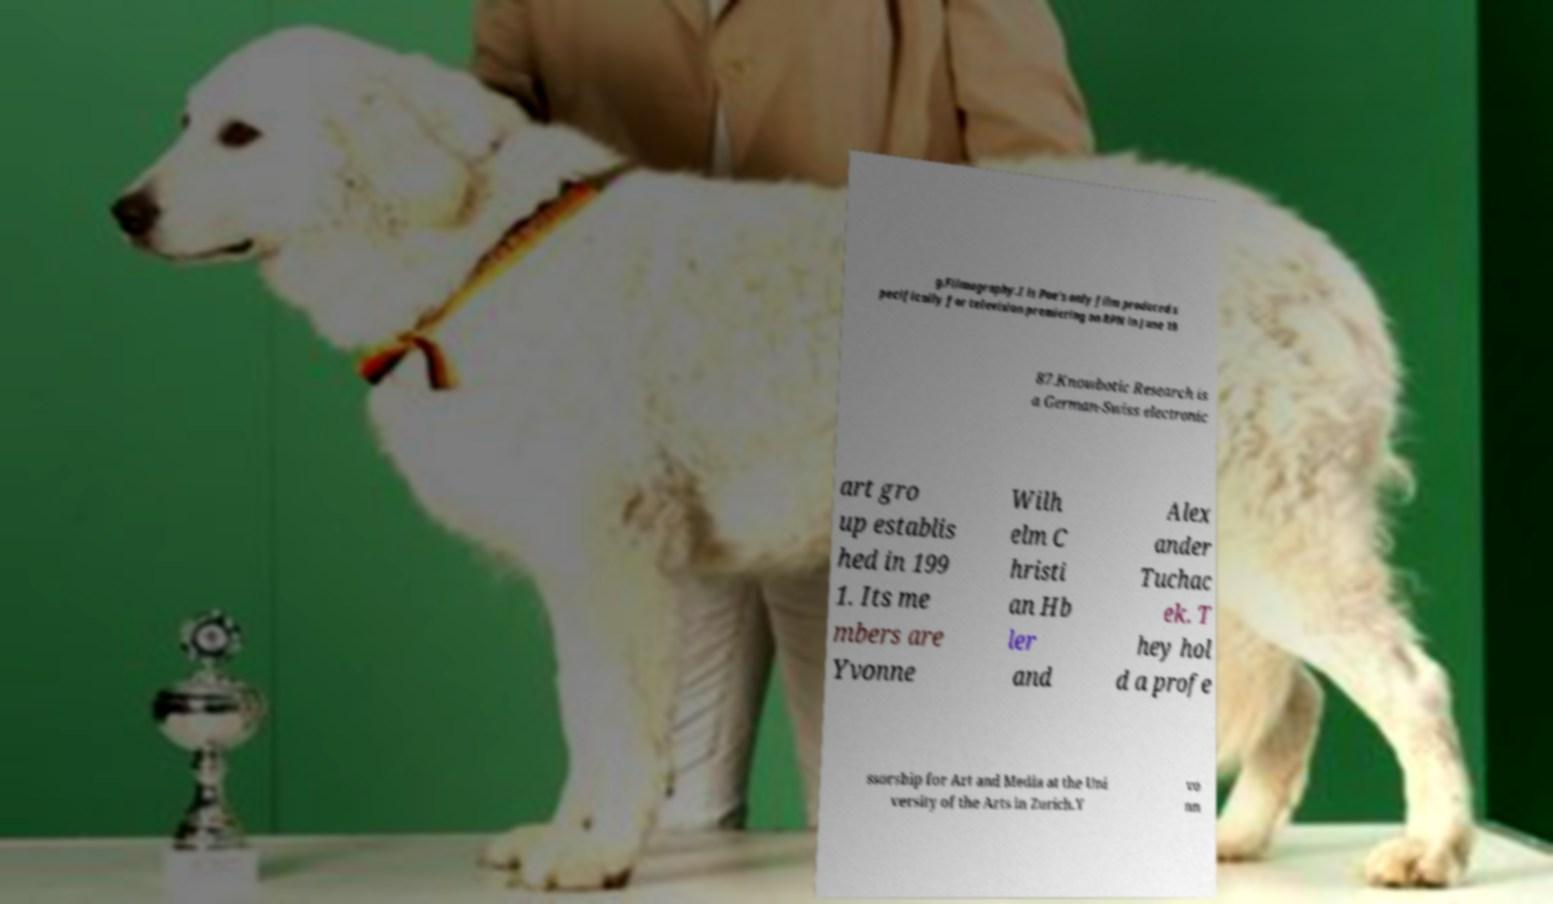Please identify and transcribe the text found in this image. g.Filmography.I is Poe's only film produced s pecifically for television premiering on RPN in June 19 87.Knowbotic Research is a German-Swiss electronic art gro up establis hed in 199 1. Its me mbers are Yvonne Wilh elm C hristi an Hb ler and Alex ander Tuchac ek. T hey hol d a profe ssorship for Art and Media at the Uni versity of the Arts in Zurich.Y vo nn 